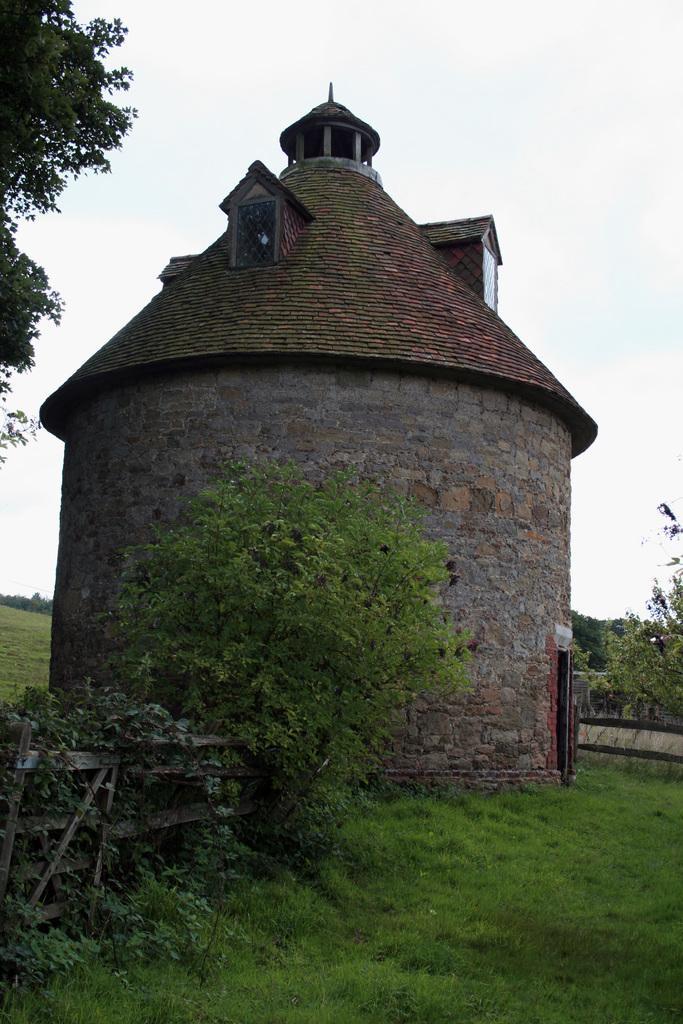Could you give a brief overview of what you see in this image? In this image we can see a house. There is a grassy land in the image. There are many trees and plants in the image. We can see the sky in the image. 